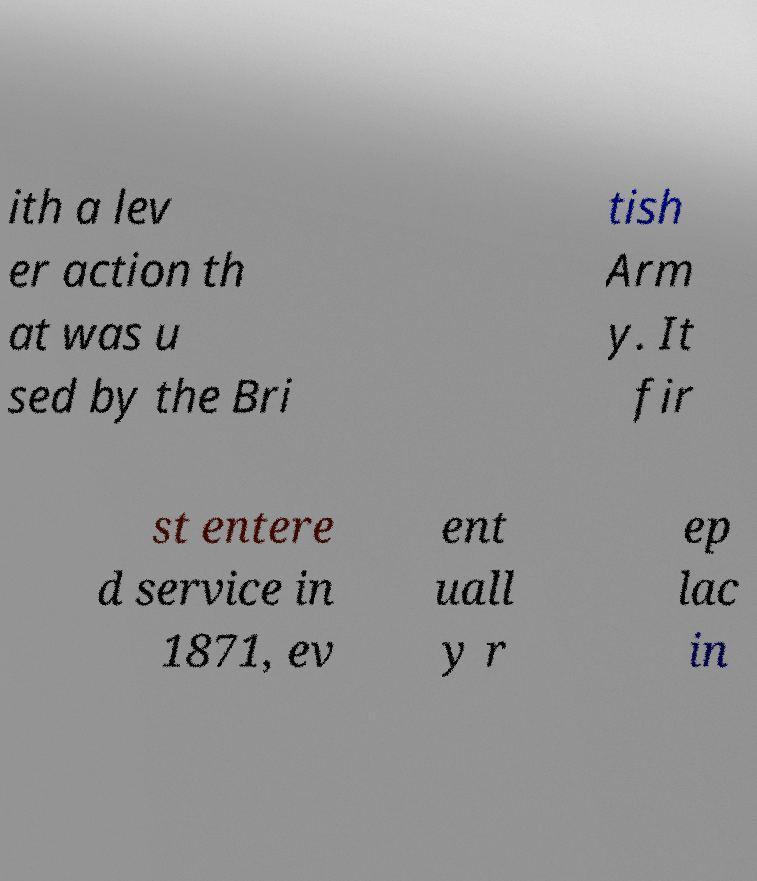For documentation purposes, I need the text within this image transcribed. Could you provide that? ith a lev er action th at was u sed by the Bri tish Arm y. It fir st entere d service in 1871, ev ent uall y r ep lac in 